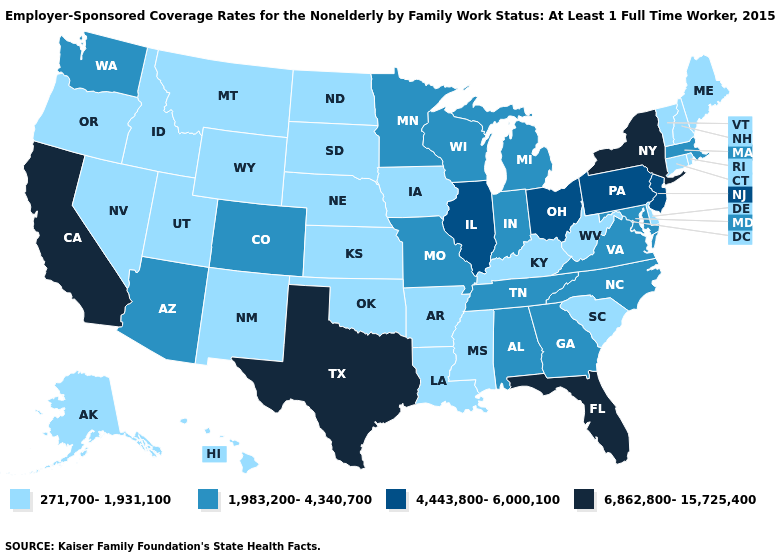What is the lowest value in states that border Massachusetts?
Write a very short answer. 271,700-1,931,100. Does New Mexico have the highest value in the West?
Answer briefly. No. Which states have the lowest value in the USA?
Answer briefly. Alaska, Arkansas, Connecticut, Delaware, Hawaii, Idaho, Iowa, Kansas, Kentucky, Louisiana, Maine, Mississippi, Montana, Nebraska, Nevada, New Hampshire, New Mexico, North Dakota, Oklahoma, Oregon, Rhode Island, South Carolina, South Dakota, Utah, Vermont, West Virginia, Wyoming. What is the value of Michigan?
Short answer required. 1,983,200-4,340,700. Name the states that have a value in the range 1,983,200-4,340,700?
Concise answer only. Alabama, Arizona, Colorado, Georgia, Indiana, Maryland, Massachusetts, Michigan, Minnesota, Missouri, North Carolina, Tennessee, Virginia, Washington, Wisconsin. What is the value of Connecticut?
Write a very short answer. 271,700-1,931,100. Does Georgia have the same value as Alabama?
Short answer required. Yes. Among the states that border New York , which have the lowest value?
Give a very brief answer. Connecticut, Vermont. Does Connecticut have the lowest value in the Northeast?
Answer briefly. Yes. Does Rhode Island have the same value as Massachusetts?
Be succinct. No. Does Texas have the highest value in the USA?
Give a very brief answer. Yes. Does Alabama have the same value as Colorado?
Keep it brief. Yes. Name the states that have a value in the range 271,700-1,931,100?
Short answer required. Alaska, Arkansas, Connecticut, Delaware, Hawaii, Idaho, Iowa, Kansas, Kentucky, Louisiana, Maine, Mississippi, Montana, Nebraska, Nevada, New Hampshire, New Mexico, North Dakota, Oklahoma, Oregon, Rhode Island, South Carolina, South Dakota, Utah, Vermont, West Virginia, Wyoming. What is the lowest value in the MidWest?
Give a very brief answer. 271,700-1,931,100. What is the highest value in the MidWest ?
Keep it brief. 4,443,800-6,000,100. 